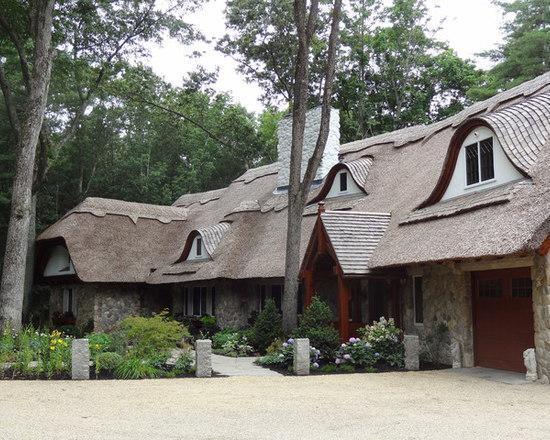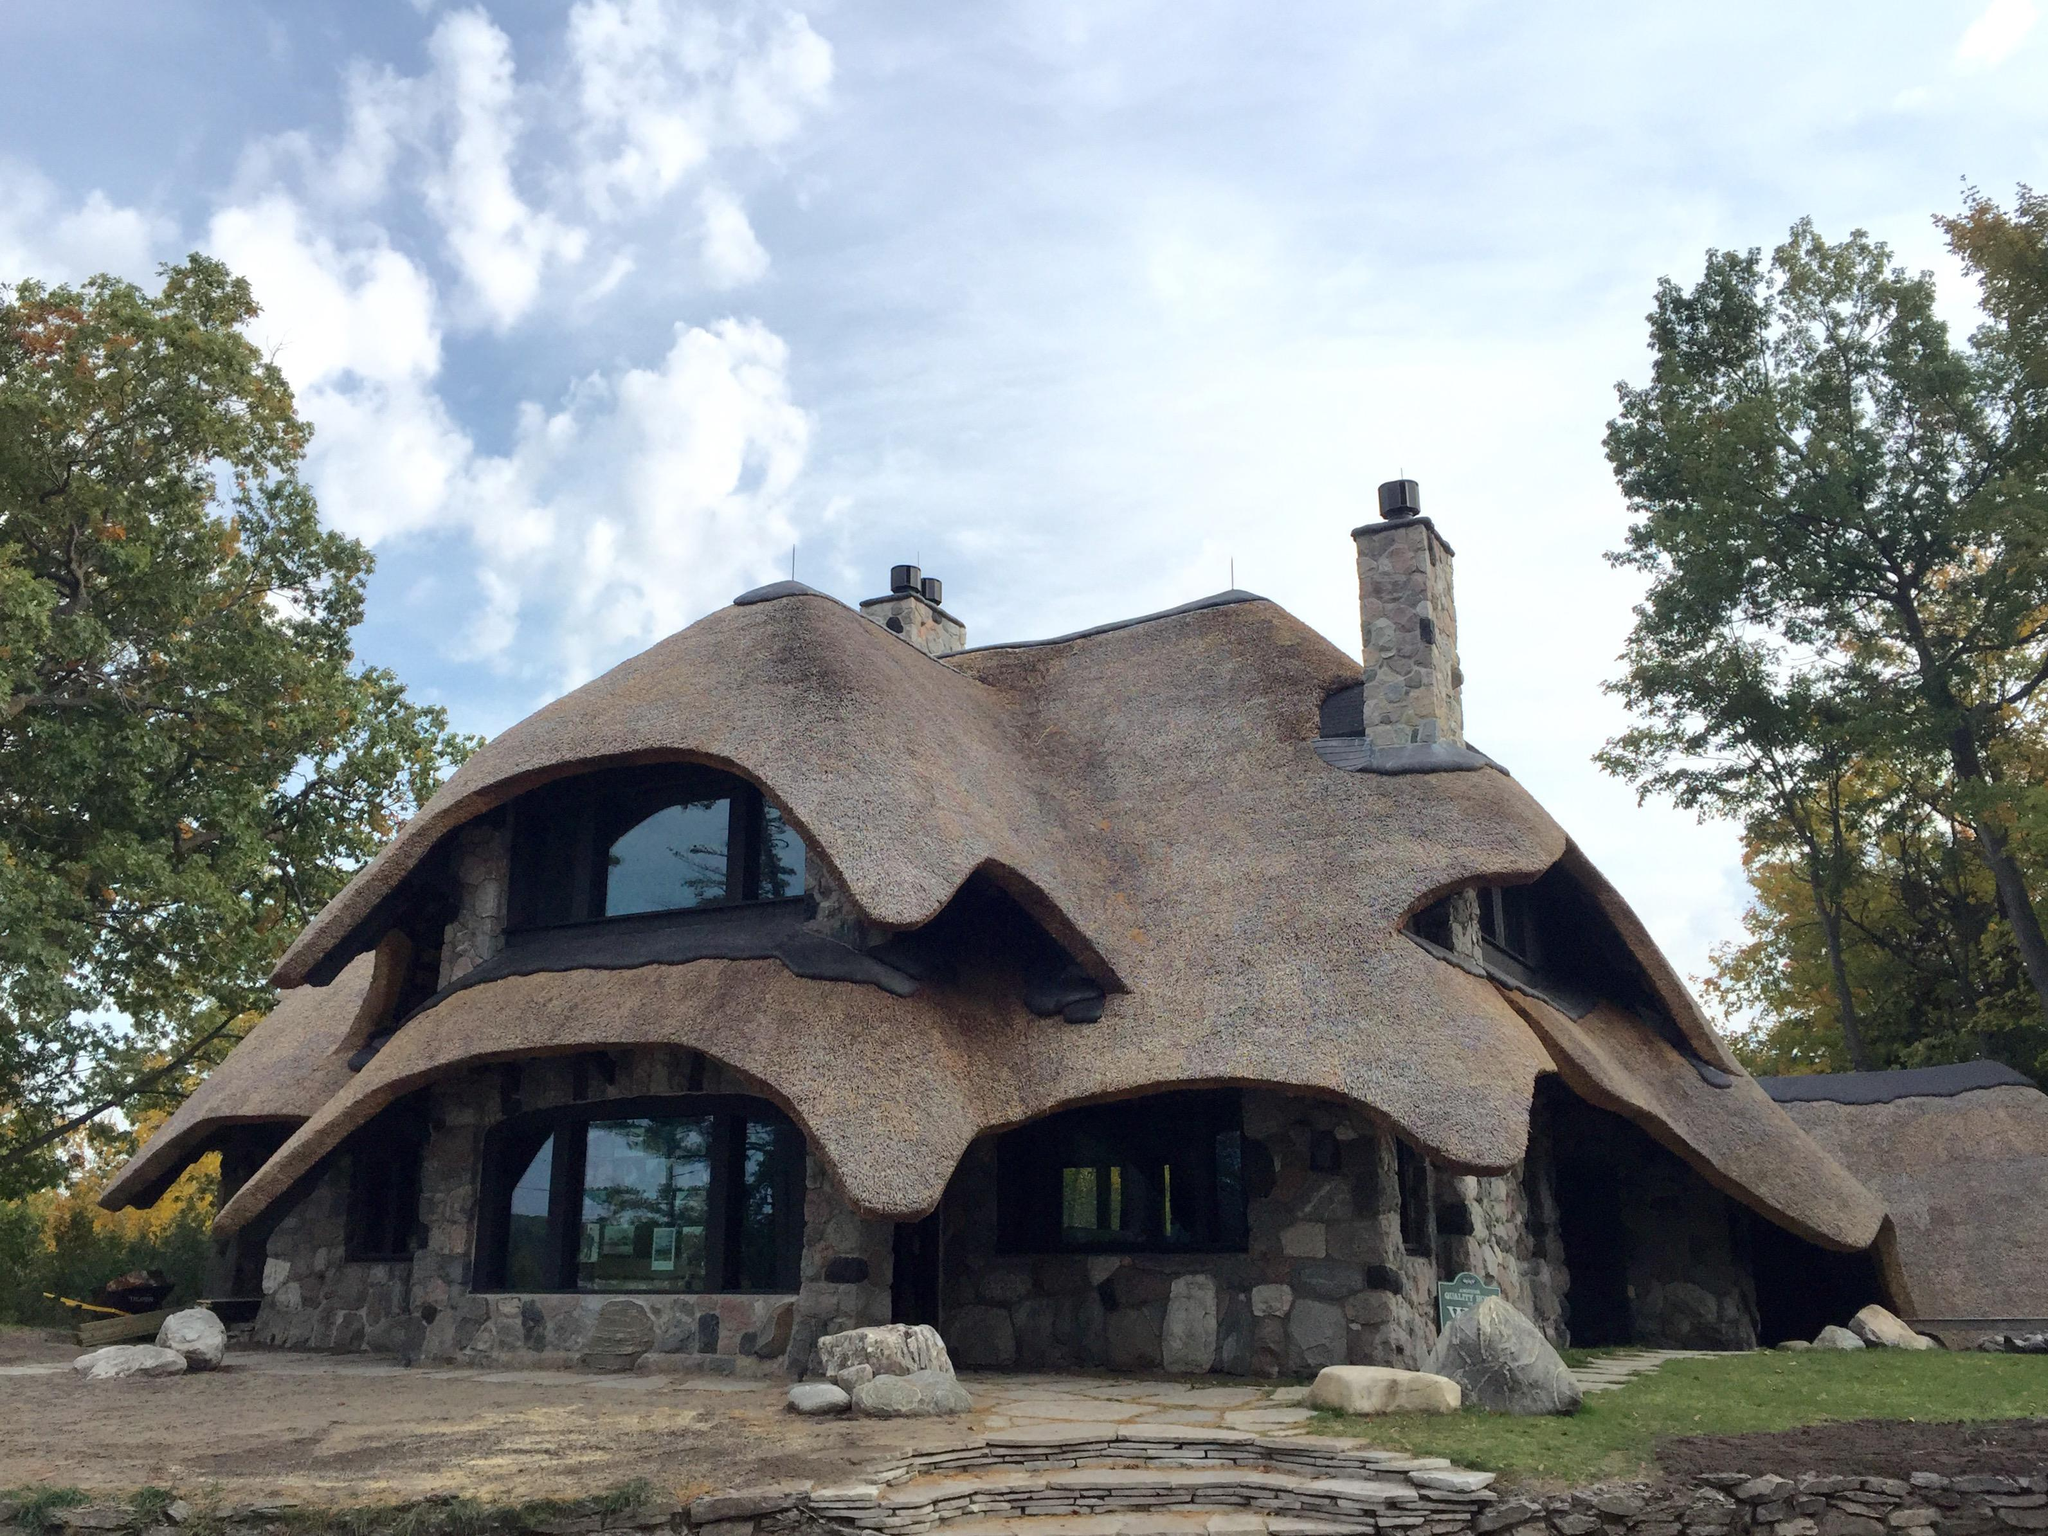The first image is the image on the left, the second image is the image on the right. Assess this claim about the two images: "In at least one image there is a house with a rounded roof and two chimney.". Correct or not? Answer yes or no. Yes. The first image is the image on the left, the second image is the image on the right. Examine the images to the left and right. Is the description "The right image shows a left-facing home with two chimneys on a roof that forms at least one overhanging arch over a window." accurate? Answer yes or no. Yes. 